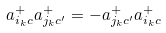<formula> <loc_0><loc_0><loc_500><loc_500>a _ { i _ { k } c } ^ { + } a _ { j _ { k } c ^ { \prime } } ^ { + } = - a _ { j _ { k } c ^ { \prime } } ^ { + } a _ { i _ { k } c } ^ { + }</formula> 